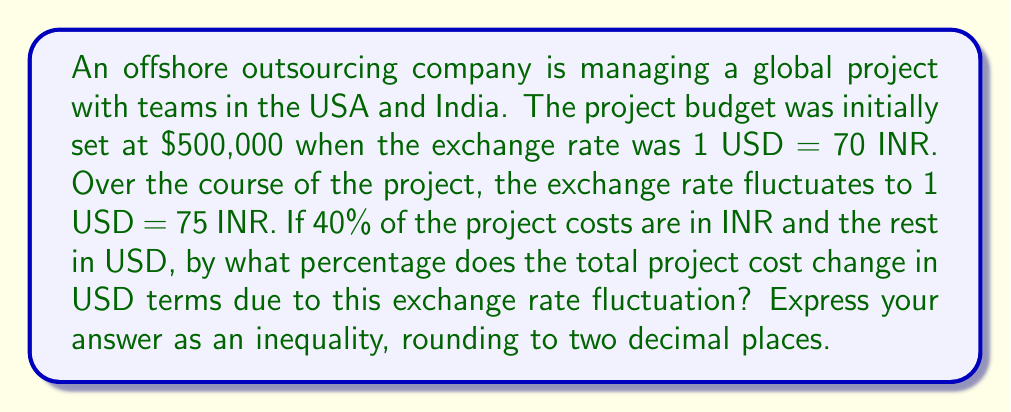Help me with this question. Let's approach this step-by-step:

1) First, let's split the budget into USD and INR portions:
   USD portion: $500,000 * 60% = $300,000
   INR portion: $500,000 * 40% = $200,000

2) At the initial exchange rate, the INR portion in rupees is:
   $200,000 * 70 INR/USD = 14,000,000 INR

3) When the exchange rate changes to 1 USD = 75 INR, we need to convert this INR amount back to USD:
   14,000,000 INR ÷ 75 INR/USD = $186,666.67

4) Now, the total project cost in USD becomes:
   $300,000 (USD portion) + $186,666.67 (new INR portion in USD) = $486,666.67

5) To calculate the percentage change:
   $$\text{Percentage Change} = \frac{\text{New Value} - \text{Original Value}}{\text{Original Value}} \times 100\%$$
   $$= \frac{486,666.67 - 500,000}{500,000} \times 100\%$$
   $$= -2.6667\%$$

6) Rounding to two decimal places: -2.67%

7) To express this as an inequality, we can say the change is less than -2.66% but greater than -2.68%:

   $$-2.68\% < \text{Percentage Change} < -2.66\%$$
Answer: $$-2.68\% < \text{Percentage Change} < -2.66\%$$ 